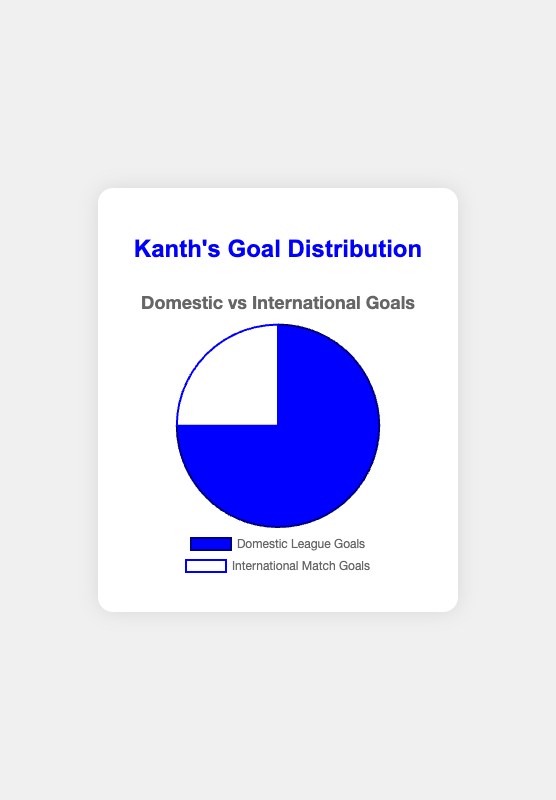What is the percentage of Kanth's goals scored in domestic league matches? To find the percentage of goals scored in domestic league matches, divide the number of domestic league goals by the total number of goals and multiply by 100. The calculation is (75 / (75 + 25)) * 100 = 75%.
Answer: 75% What is the difference between the number of goals Kanth scored in domestic league matches and international matches? To find the difference, subtract the number of international match goals from the number of domestic league goals: 75 - 25 = 50.
Answer: 50 Which category has more goals, Domestic League Goals or International Match Goals? Compare the two values: Domestic League Goals (75) and International Match Goals (25). Domestic League Goals have more.
Answer: Domestic League Goals What is the ratio of domestic league goals to international match goals for Kanth? Divide the number of domestic league goals by the number of international match goals: 75 / 25 = 3. Hence, the ratio is 3:1.
Answer: 3:1 If Kanth scores 10 more goals in international matches, will the number of goals in domestic league matches still be greater? Adding 10 to the current international match goals: 25 + 10 = 35. Compare this with domestic league goals: 75 > 35. Domestic league goals will still be greater.
Answer: Yes What fraction of Kanth's total goals is from international matches? The fraction is given by the number of international match goals divided by the total number of goals: 25 / (75 + 25) = 25 / 100 = 1/4.
Answer: 1/4 If Kanth’s total goals increase by 20%, what will be the new total count? First, find the current total goals: 75 + 25 = 100. An increase of 20% is calculated by (100 * 0.20) + 100 = 20 + 100 = 120.
Answer: 120 How does the color coding of categories help in distinguishing between domestic league goals and international match goals? The chart uses blue for domestic league goals and white for international match goals, making it easy to visually differentiate between the two categories.
Answer: Color coding aids distinction What is the total number of goals Kanth scored? Sum the number of goals from both categories: 75 (Domestic League) + 25 (International Matches) = 100.
Answer: 100 If the number of international match goals doubles, what percentage of the total will be from international matches? Doubling international match goals: 25 * 2 = 50. New total of goals: 75 (Domestic) + 50 (International) = 125. Percentage: (50 / 125) * 100 = 40%.
Answer: 40% 